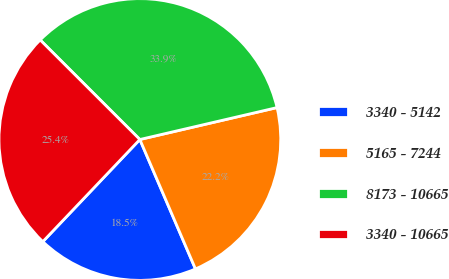Convert chart. <chart><loc_0><loc_0><loc_500><loc_500><pie_chart><fcel>3340 - 5142<fcel>5165 - 7244<fcel>8173 - 10665<fcel>3340 - 10665<nl><fcel>18.55%<fcel>22.18%<fcel>33.87%<fcel>25.4%<nl></chart> 